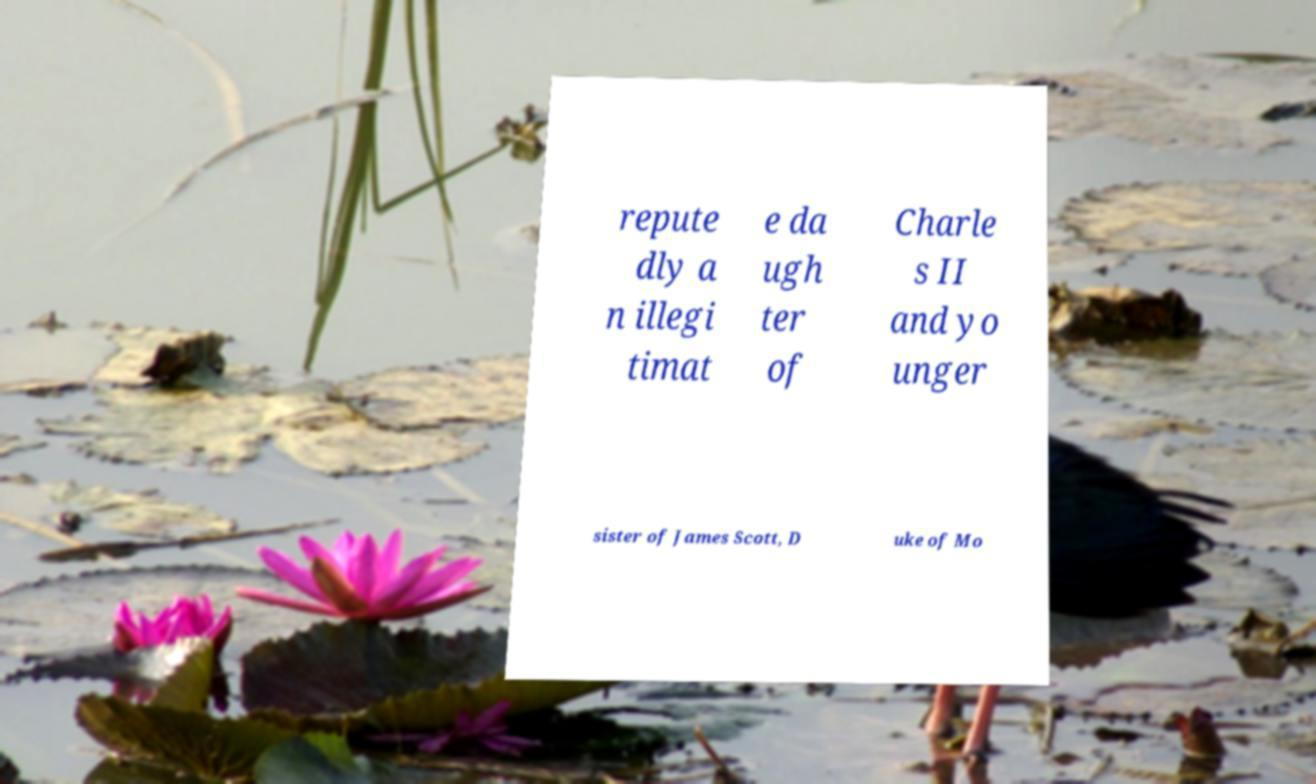I need the written content from this picture converted into text. Can you do that? repute dly a n illegi timat e da ugh ter of Charle s II and yo unger sister of James Scott, D uke of Mo 